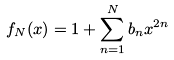<formula> <loc_0><loc_0><loc_500><loc_500>f _ { N } ( x ) = 1 + \sum _ { n = 1 } ^ { N } b _ { n } x ^ { 2 n }</formula> 